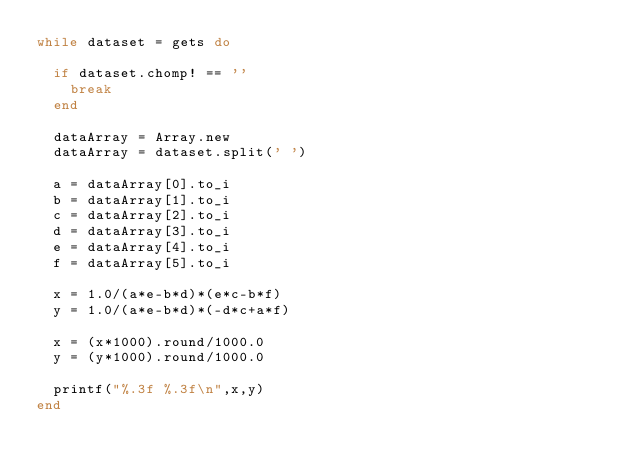Convert code to text. <code><loc_0><loc_0><loc_500><loc_500><_Ruby_>while dataset = gets do

  if dataset.chomp! == ''
    break
  end

  dataArray = Array.new
  dataArray = dataset.split(' ')

  a = dataArray[0].to_i
  b = dataArray[1].to_i
  c = dataArray[2].to_i
  d = dataArray[3].to_i
  e = dataArray[4].to_i
  f = dataArray[5].to_i

  x = 1.0/(a*e-b*d)*(e*c-b*f)
  y = 1.0/(a*e-b*d)*(-d*c+a*f)

  x = (x*1000).round/1000.0
  y = (y*1000).round/1000.0

  printf("%.3f %.3f\n",x,y)
end</code> 